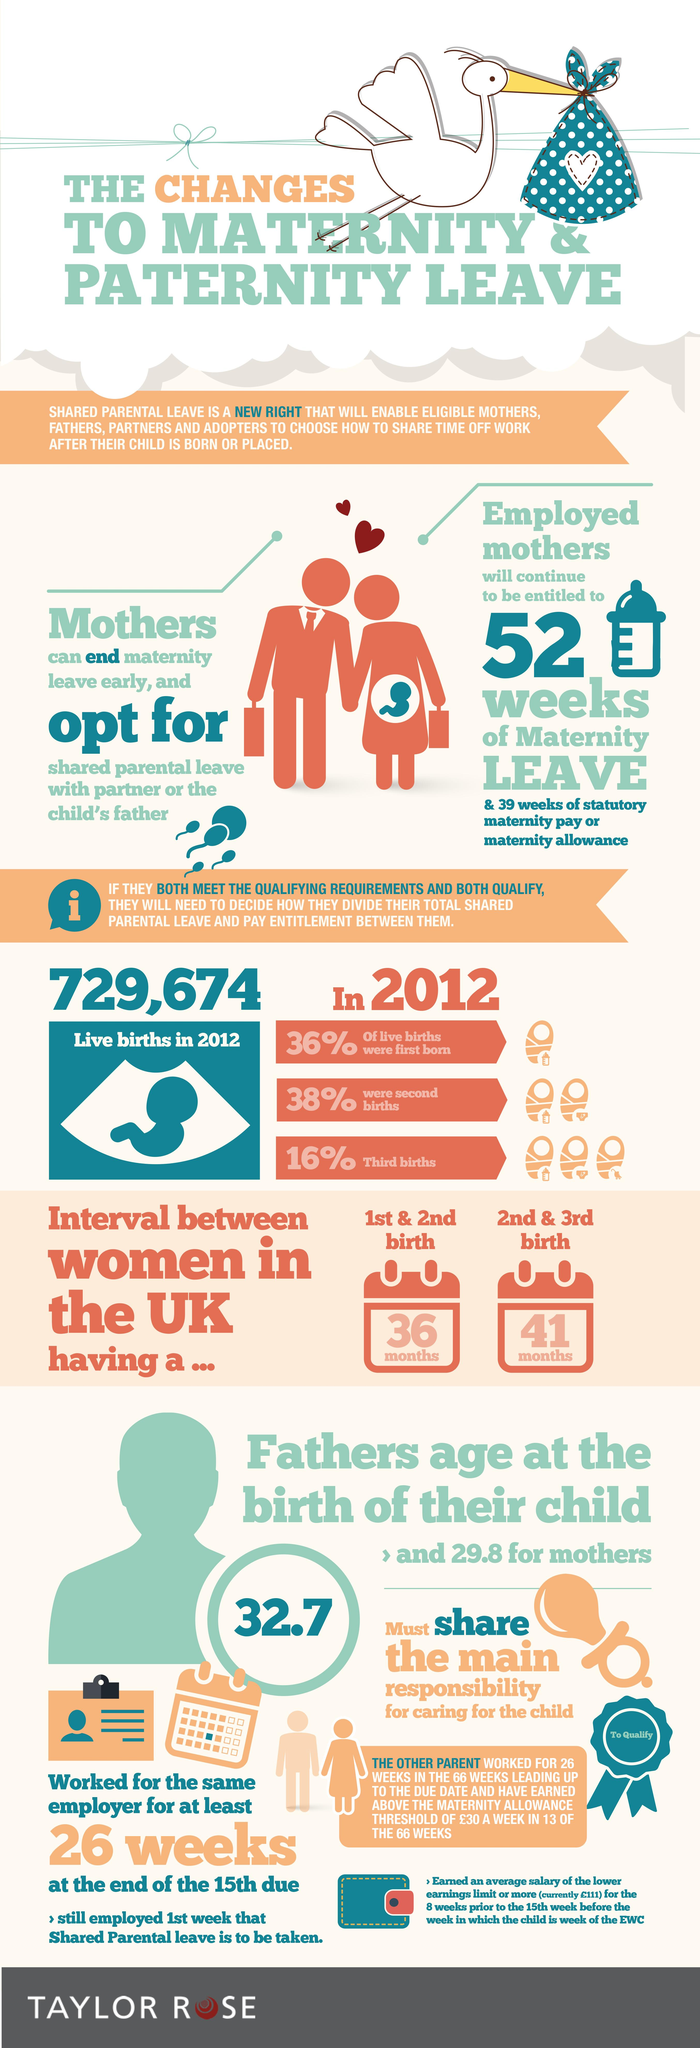Specify some key components in this picture. In 2012, the highest number of live births was second births. The average age of a father at the birth of their child is 32.7 years. According to data from 2012, approximately 36% of all live births occurred that year. According to data, the average age of mothers at the birth of their child is 29.8 years old. 